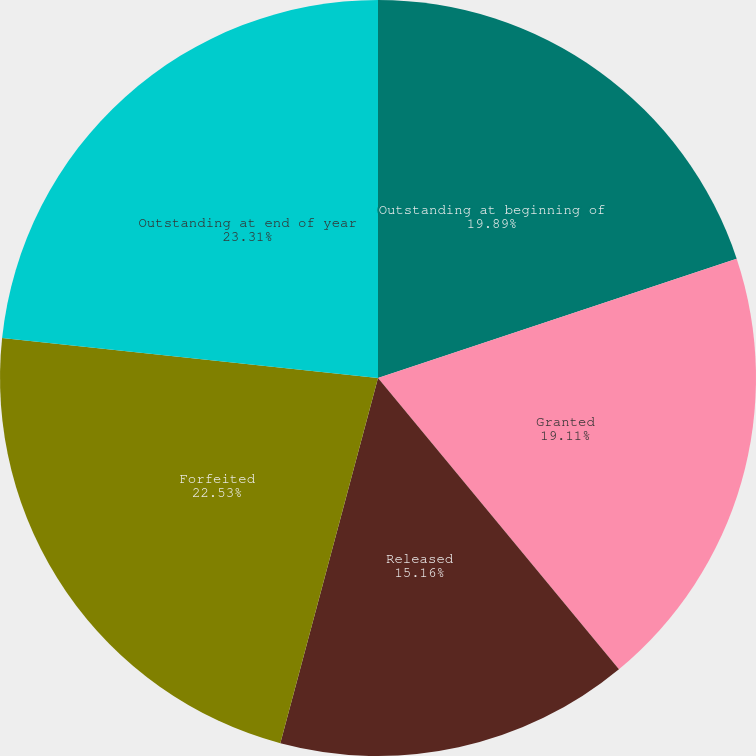Convert chart to OTSL. <chart><loc_0><loc_0><loc_500><loc_500><pie_chart><fcel>Outstanding at beginning of<fcel>Granted<fcel>Released<fcel>Forfeited<fcel>Outstanding at end of year<nl><fcel>19.89%<fcel>19.11%<fcel>15.16%<fcel>22.53%<fcel>23.31%<nl></chart> 